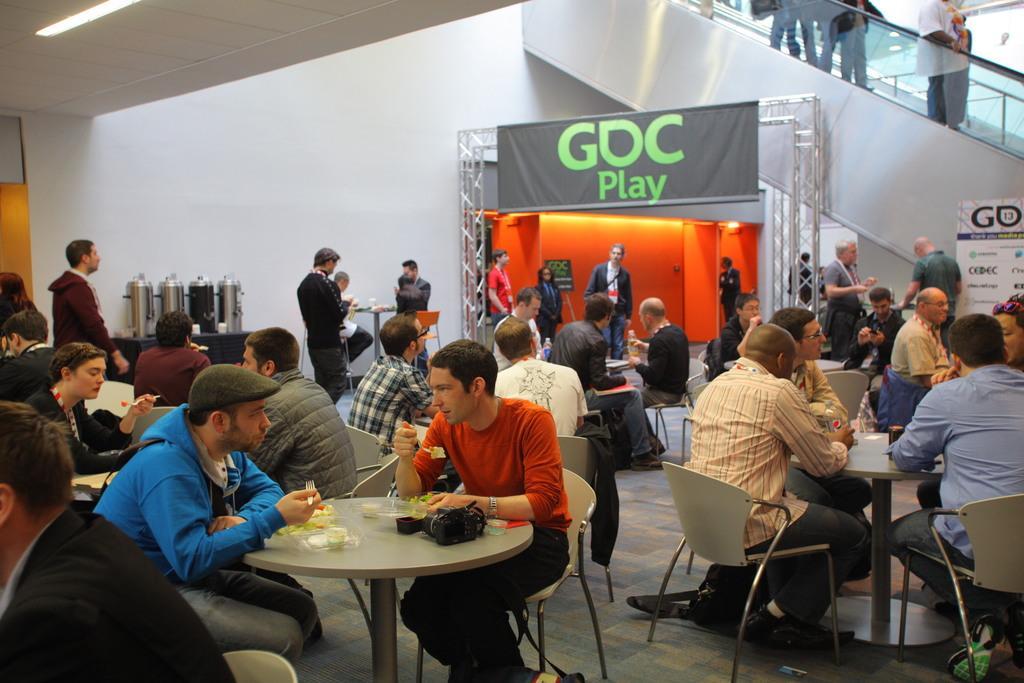Could you give a brief overview of what you see in this image? Most of the persons are sitting on chairs. In-front of them there are tables, on this table there is a camera, glass and food. A banner is attached to the grill. On this stage persons are standing. Wall is in orange color. Persons are standing on a escalator. Far on the table there are cylinders. 